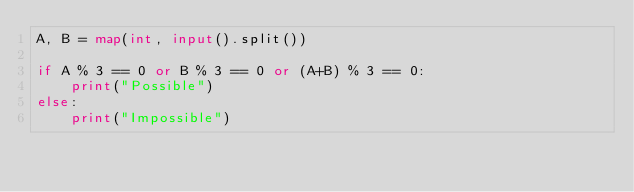Convert code to text. <code><loc_0><loc_0><loc_500><loc_500><_Python_>A, B = map(int, input().split())

if A % 3 == 0 or B % 3 == 0 or (A+B) % 3 == 0:
    print("Possible")
else:
    print("Impossible")
</code> 